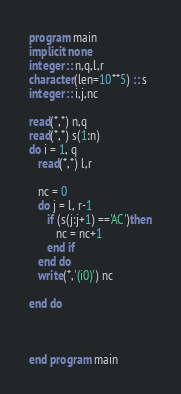Convert code to text. <code><loc_0><loc_0><loc_500><loc_500><_FORTRAN_>program main
implicit none
integer :: n,q,l,r
character(len=10**5) :: s
integer :: i,j,nc

read(*,*) n,q
read(*,*) s(1:n)
do i = 1, q
   read(*,*) l,r
   
   nc = 0
   do j = l, r-1
      if (s(j:j+1) =='AC')then
         nc = nc+1
      end if
   end do
   write(*,'(i0)') nc

end do



end program main
</code> 